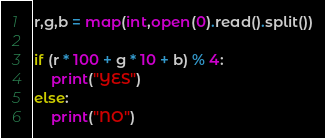<code> <loc_0><loc_0><loc_500><loc_500><_Python_>r,g,b = map(int,open(0).read().split())

if (r * 100 + g * 10 + b) % 4:
    print("YES")
else:
    print("NO")</code> 